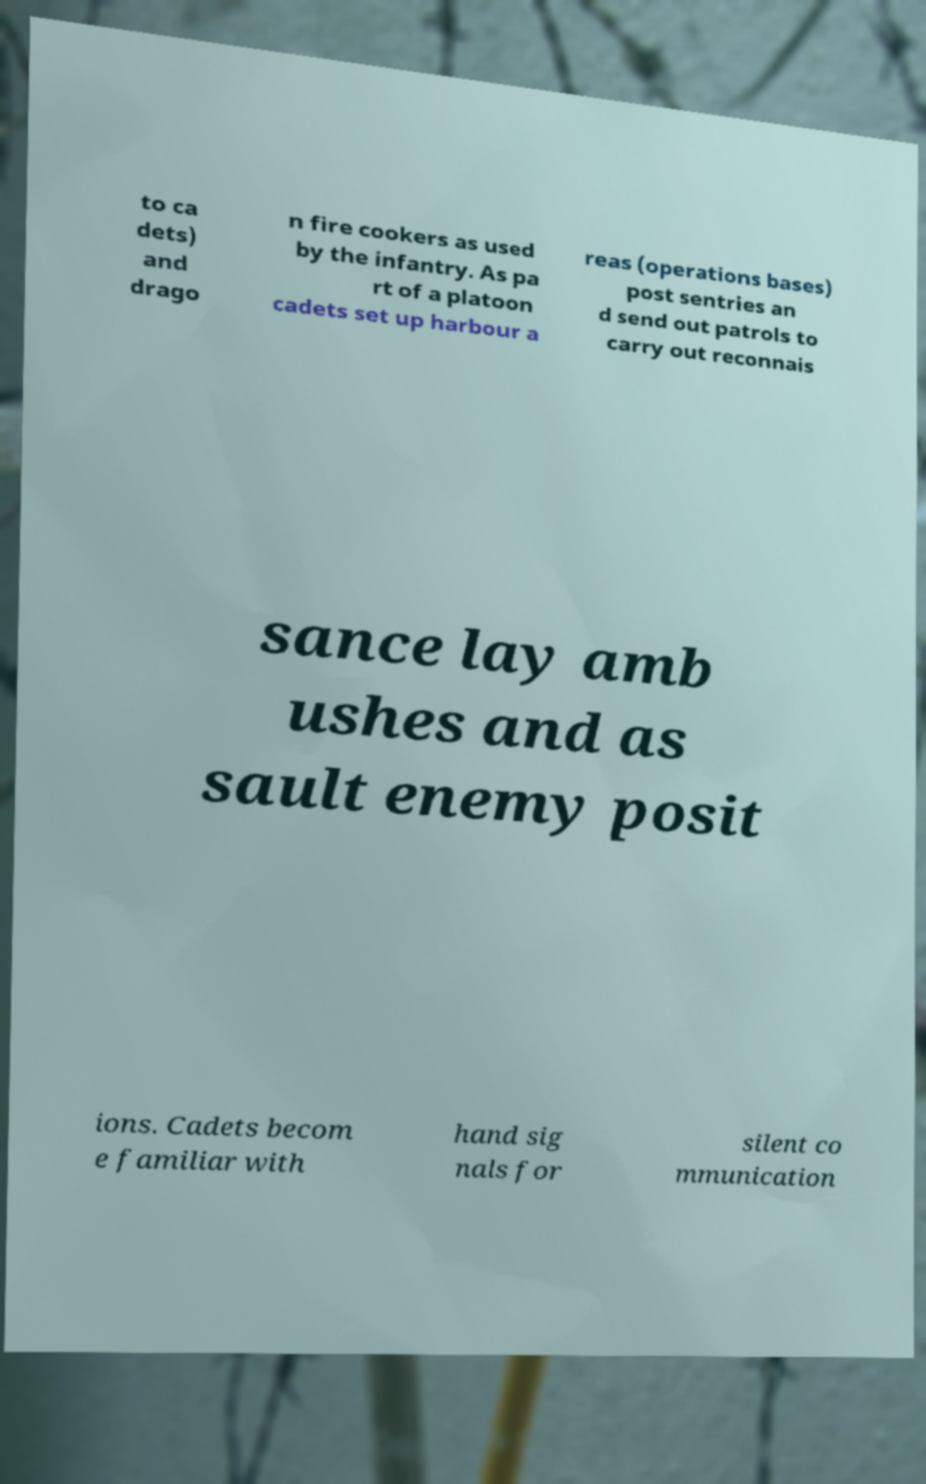Could you assist in decoding the text presented in this image and type it out clearly? to ca dets) and drago n fire cookers as used by the infantry. As pa rt of a platoon cadets set up harbour a reas (operations bases) post sentries an d send out patrols to carry out reconnais sance lay amb ushes and as sault enemy posit ions. Cadets becom e familiar with hand sig nals for silent co mmunication 